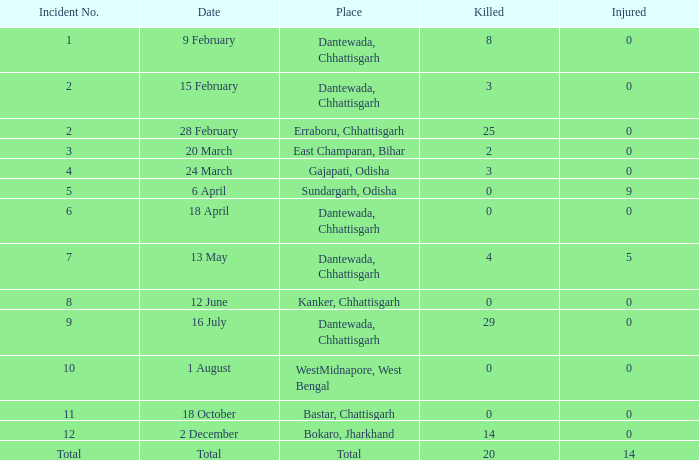How many people were injured in total in East Champaran, Bihar with more than 2 people killed? 0.0. 